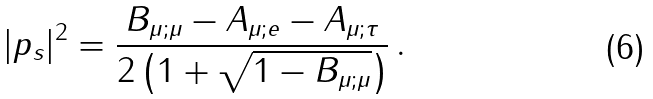<formula> <loc_0><loc_0><loc_500><loc_500>| p _ { s } | ^ { 2 } = \frac { B _ { \mu ; \mu } - A _ { \mu ; e } - A _ { \mu ; \tau } } { 2 \left ( 1 + \sqrt { 1 - B _ { \mu ; \mu } } \right ) } \, .</formula> 